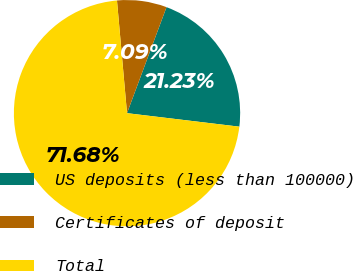Convert chart to OTSL. <chart><loc_0><loc_0><loc_500><loc_500><pie_chart><fcel>US deposits (less than 100000)<fcel>Certificates of deposit<fcel>Total<nl><fcel>21.23%<fcel>7.09%<fcel>71.68%<nl></chart> 